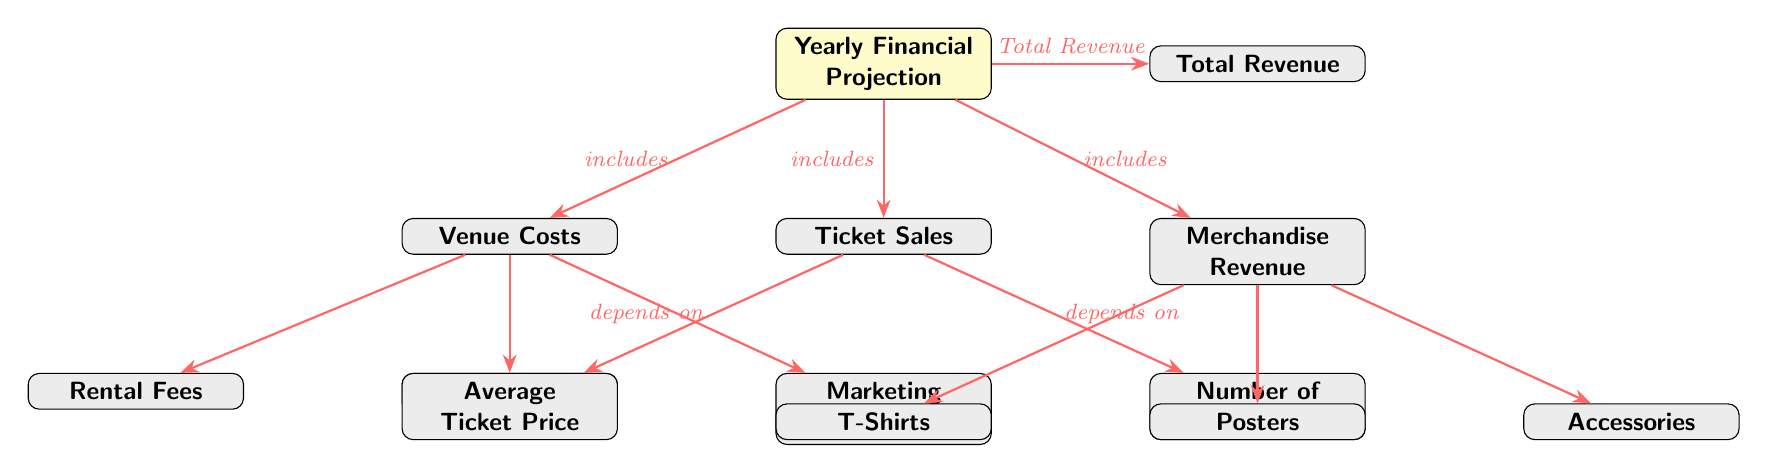What are the three main components of the yearly financial projection? The diagram lists three main components connected to the central node labeled "Yearly Financial Projection": Venue Costs, Ticket Sales, and Merchandise Revenue.
Answer: Venue Costs, Ticket Sales, Merchandise Revenue How many nodes are there in total in the diagram? The diagram contains a total of 7 nodes: 1 main node and 6 connecting nodes (3 for Venue Costs, 2 for Ticket Sales, and 3 for Merchandise Revenue).
Answer: 7 What does "Total Revenue" depend on? "Total Revenue" is an aggregate of the three components: Venue Costs, Ticket Sales, and Merchandise Revenue. Therefore, it directly depends on the summation of these components.
Answer: Venue Costs, Ticket Sales, Merchandise Revenue What type of expenses are included under Venue Costs? The expenses under Venue Costs include Rental Fees, Staff Payments, and Marketing Expenses, as illustrated in the lower branches connected to the Venue Costs node.
Answer: Rental Fees, Staff Payments, Marketing Expenses Which two factors affect Ticket Sales? The Ticket Sales node has two factors that influence it: Average Ticket Price and Number of Tickets Sold, which are shown as the lower nodes branching from Ticket Sales.
Answer: Average Ticket Price, Number of Tickets Sold What types of merchandise revenue are included? The Merchandise Revenue node includes three types: T-Shirts, Posters, and Accessories, which are indicated as the lower branches under the Merchandise Revenue node.
Answer: T-Shirts, Posters, Accessories What is the relationship between the main node and the merchandise node? The relationship is that the main node ("Yearly Financial Projection") includes the "Merchandise Revenue" node, indicating that merchandise sales are part of the overall financial projection.
Answer: Includes Which category has the most detailed breakdown in the diagram? The Venue Costs category has the most detailed breakdown, having three sub-components: Rental Fees, Staff Payments, and Marketing Expenses, whereas the other categories have fewer components.
Answer: Venue Costs How many sub-categories does Merchandise Revenue have? Merchandise Revenue has three sub-categories, which are T-Shirts, Posters, and Accessories, represented as lower nodes under the Merchandise Revenue node.
Answer: 3 